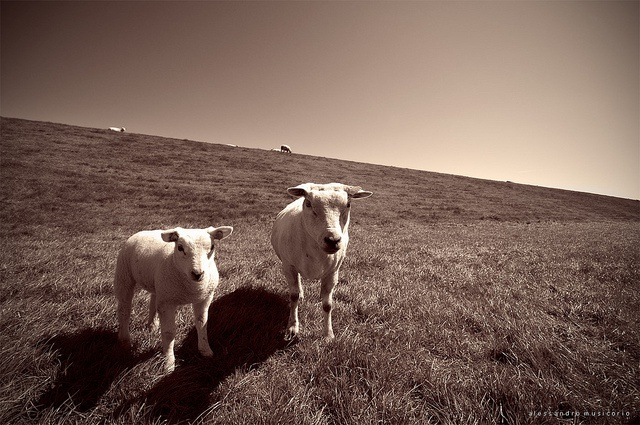Describe the objects in this image and their specific colors. I can see sheep in black, maroon, ivory, and brown tones, sheep in black, maroon, brown, and ivory tones, sheep in black, ivory, gray, maroon, and brown tones, sheep in black, ivory, and maroon tones, and sheep in black, ivory, gray, and tan tones in this image. 